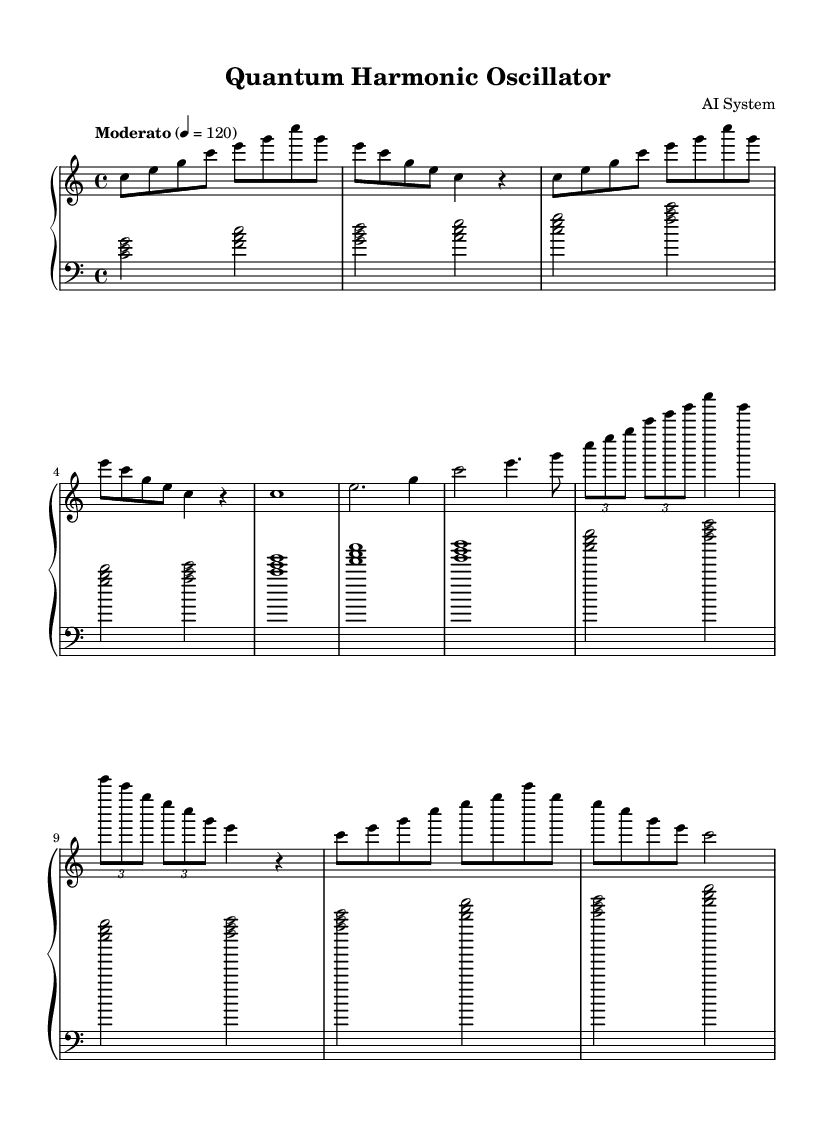What is the key signature of this music? The key signature is indicated at the beginning of the piece. It shows no sharps or flats, which establishes it in C major.
Answer: C major What is the time signature of this music? The time signature is visible at the start of the score. It is marked as 4/4, meaning there are four beats per measure, and the quarter note gets one beat.
Answer: 4/4 What is the tempo marking for this music? The tempo marking indicates the desired speed of the piece. It is listed as "Moderato," and the metronome marking is 120 beats per minute, giving a moderate pace for performance.
Answer: Moderato How many measures are included in the right hand part? To determine the number of measures, count the separate groupings of notes and rests represented in the right hand part. There are a total of 10 measures present.
Answer: 10 What is the chord progression used in the left hand? The left hand follows a common chord progression, which can be identified by inspecting the chords played. In this case, the pattern forms a progression of I - IV - V - vi, corresponding to C major, F major, G major, and A minor chords.
Answer: I - IV - V - vi What mathematical concept is represented in Theme B's duration? In Theme B, the durations follow the Fibonacci sequence, where each number in the sequence is the sum of the two preceding ones. This can be derived from the longer note durations compared to the shorter ones listed subsequently.
Answer: Fibonacci sequence How does the variation represent wave function collapse? The variation is depicted through the use of tuplets, which create an uneven rhythmic pattern that suggests the probabilistic nature of wave function collapse, contrasting the regular patterns found in the preceding themes.
Answer: Wave function collapse 